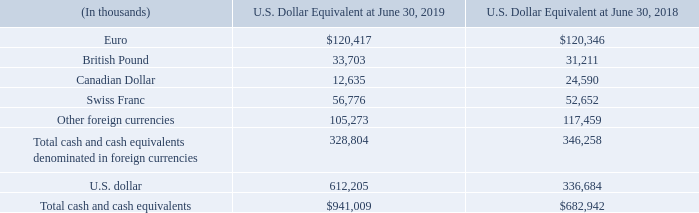Foreign currency translation risk
Our reporting currency is the U.S. dollar. Fluctuations in foreign currencies impact the amount of total assets and liabilities that we report for our foreign subsidiaries upon the translation of these amounts into U.S. dollars. In particular, the amount of cash and cash equivalents that we report in U.S. dollars for a significant portion of the cash held by these subsidiaries is subject to translation variance caused by changes in foreign currency exchange rates as of the end of each respective reporting period (the offset to which is recorded to accumulated other comprehensive income on our Consolidated Balance Sheets).
The following table shows our cash and cash equivalents denominated in certain major foreign currencies as of June 30, 2019 (equivalent in U.S. dollar):
If overall foreign currency exchange rates in comparison to the U.S. dollar uniformly weakened by 10%, the amount of cash and cash equivalents we would report in equivalent U.S. dollars would decrease by approximately $32.9 million (June 30, 2018—$34.6 million), assuming we have not entered into any derivatives discussed above under "Foreign Currency Transaction Risk".
What is the reporting currency? U.s. dollar. What does the table show? Cash and cash equivalents denominated in certain major foreign currencies as of june 30, 2019 (equivalent in u.s. dollar). If overall foreign currency exchange rates in comparison to the U.S. dollar uniformly weakened by 10%, how much would the amount of cash and cash equivalents reported in equivalent U.S. dollars decrease by? Approximately $32.9 million (june 30, 2018—$34.6 million), assuming we have not entered into any derivatives discussed above under "foreign currency transaction risk". What is the average annual fiscal year Total cash and cash equivalents?
Answer scale should be: thousand. (941,009+682,942)/2
Answer: 811975.5. At June 30, 2019, what is the Euro U.S. dollar equivalent expressed as a percentage of Total cash and cash equivalents denominated in foreign currencies?
Answer scale should be: percent. 120,417/328,804
Answer: 36.62. What is the Total cash and cash equivalents denominated in foreign currencies expressed as a percentage of Total cash and cash equivalents at June 30, 2019?
Answer scale should be: percent. 328,804/941,009
Answer: 34.94. 